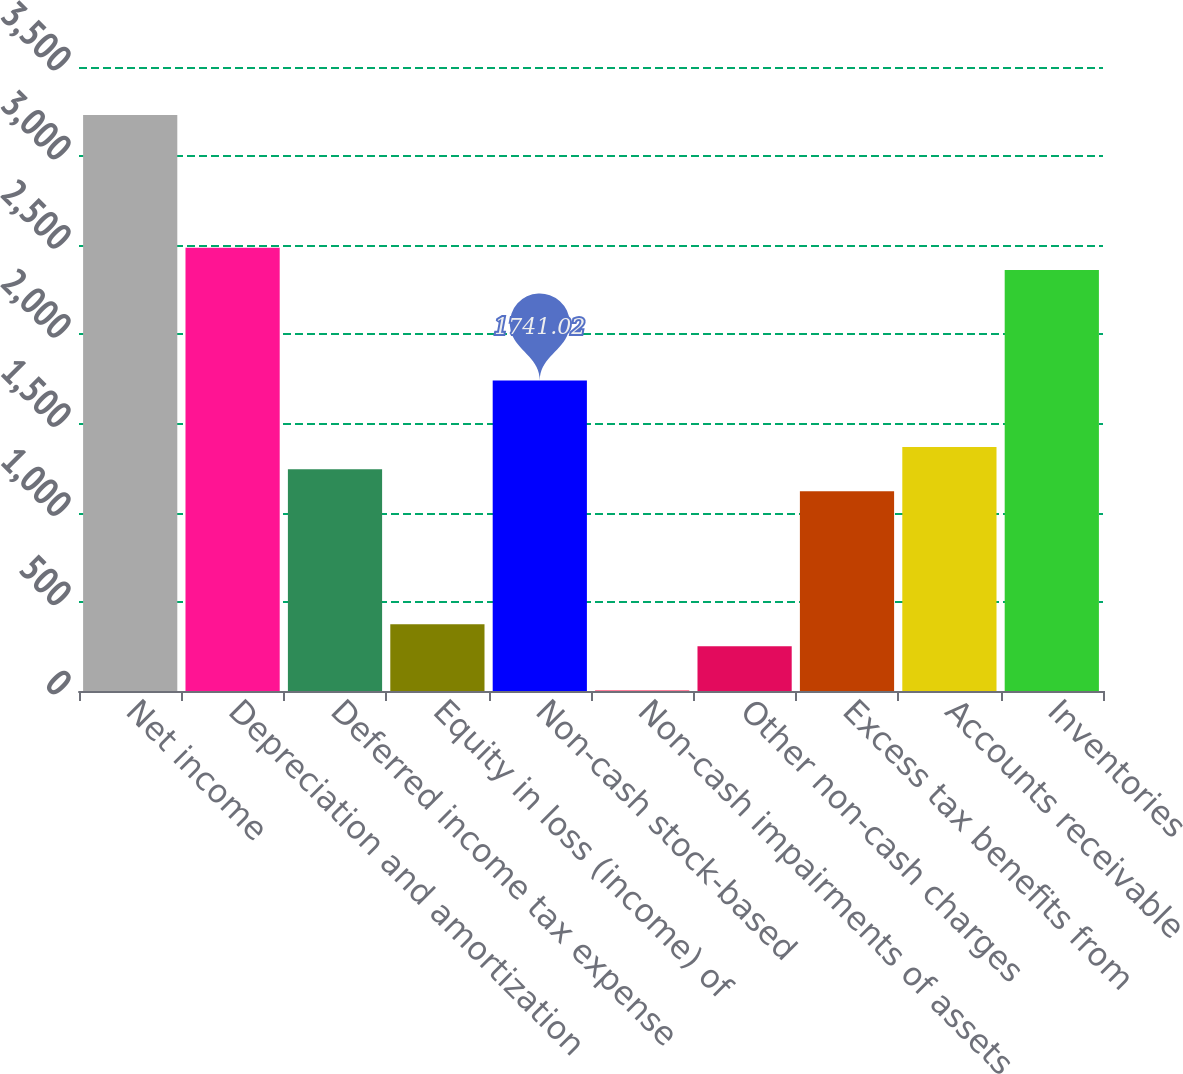Convert chart to OTSL. <chart><loc_0><loc_0><loc_500><loc_500><bar_chart><fcel>Net income<fcel>Depreciation and amortization<fcel>Deferred income tax expense<fcel>Equity in loss (income) of<fcel>Non-cash stock-based<fcel>Non-cash impairments of assets<fcel>Other non-cash charges<fcel>Excess tax benefits from<fcel>Accounts receivable<fcel>Inventories<nl><fcel>3231.18<fcel>2486.1<fcel>1244.3<fcel>375.04<fcel>1741.02<fcel>2.5<fcel>250.86<fcel>1120.12<fcel>1368.48<fcel>2361.92<nl></chart> 